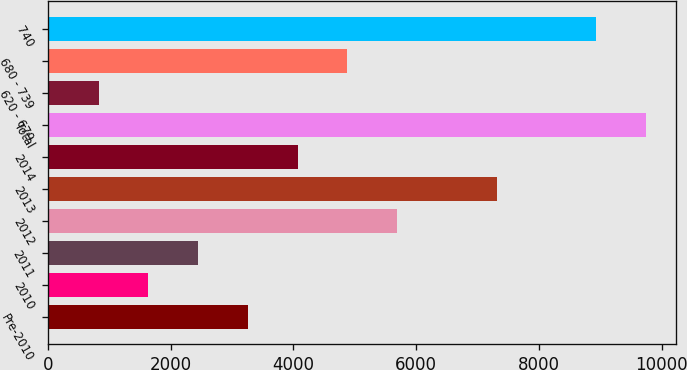<chart> <loc_0><loc_0><loc_500><loc_500><bar_chart><fcel>Pre-2010<fcel>2010<fcel>2011<fcel>2012<fcel>2013<fcel>2014<fcel>Total<fcel>620 - 679<fcel>680 - 739<fcel>740<nl><fcel>3261<fcel>1639<fcel>2450<fcel>5694<fcel>7316<fcel>4072<fcel>9749<fcel>828<fcel>4883<fcel>8938<nl></chart> 